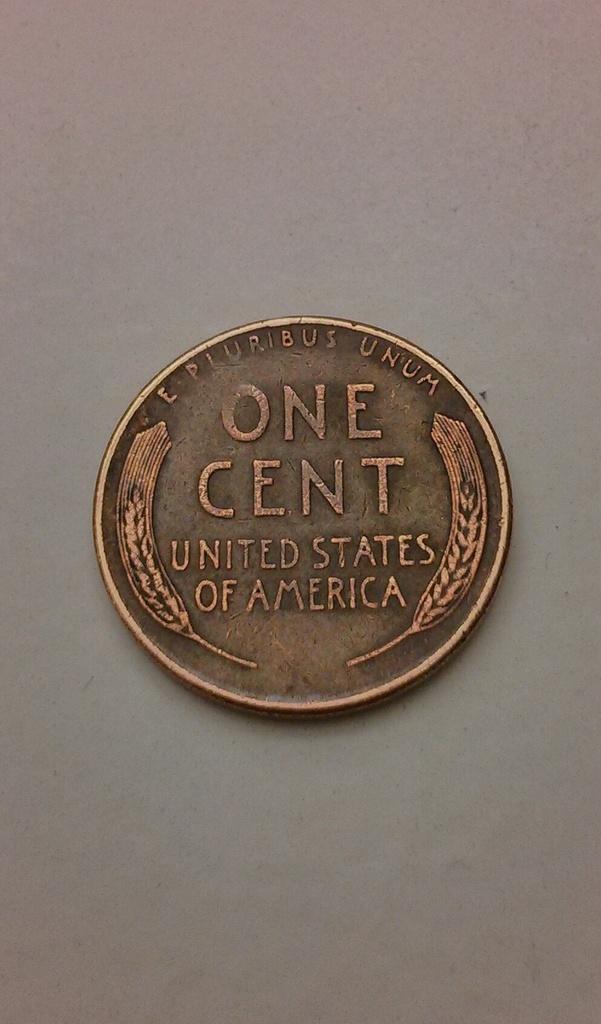What country is this?
Provide a succinct answer. United states of america. Is this one cent?
Your answer should be compact. Yes. 